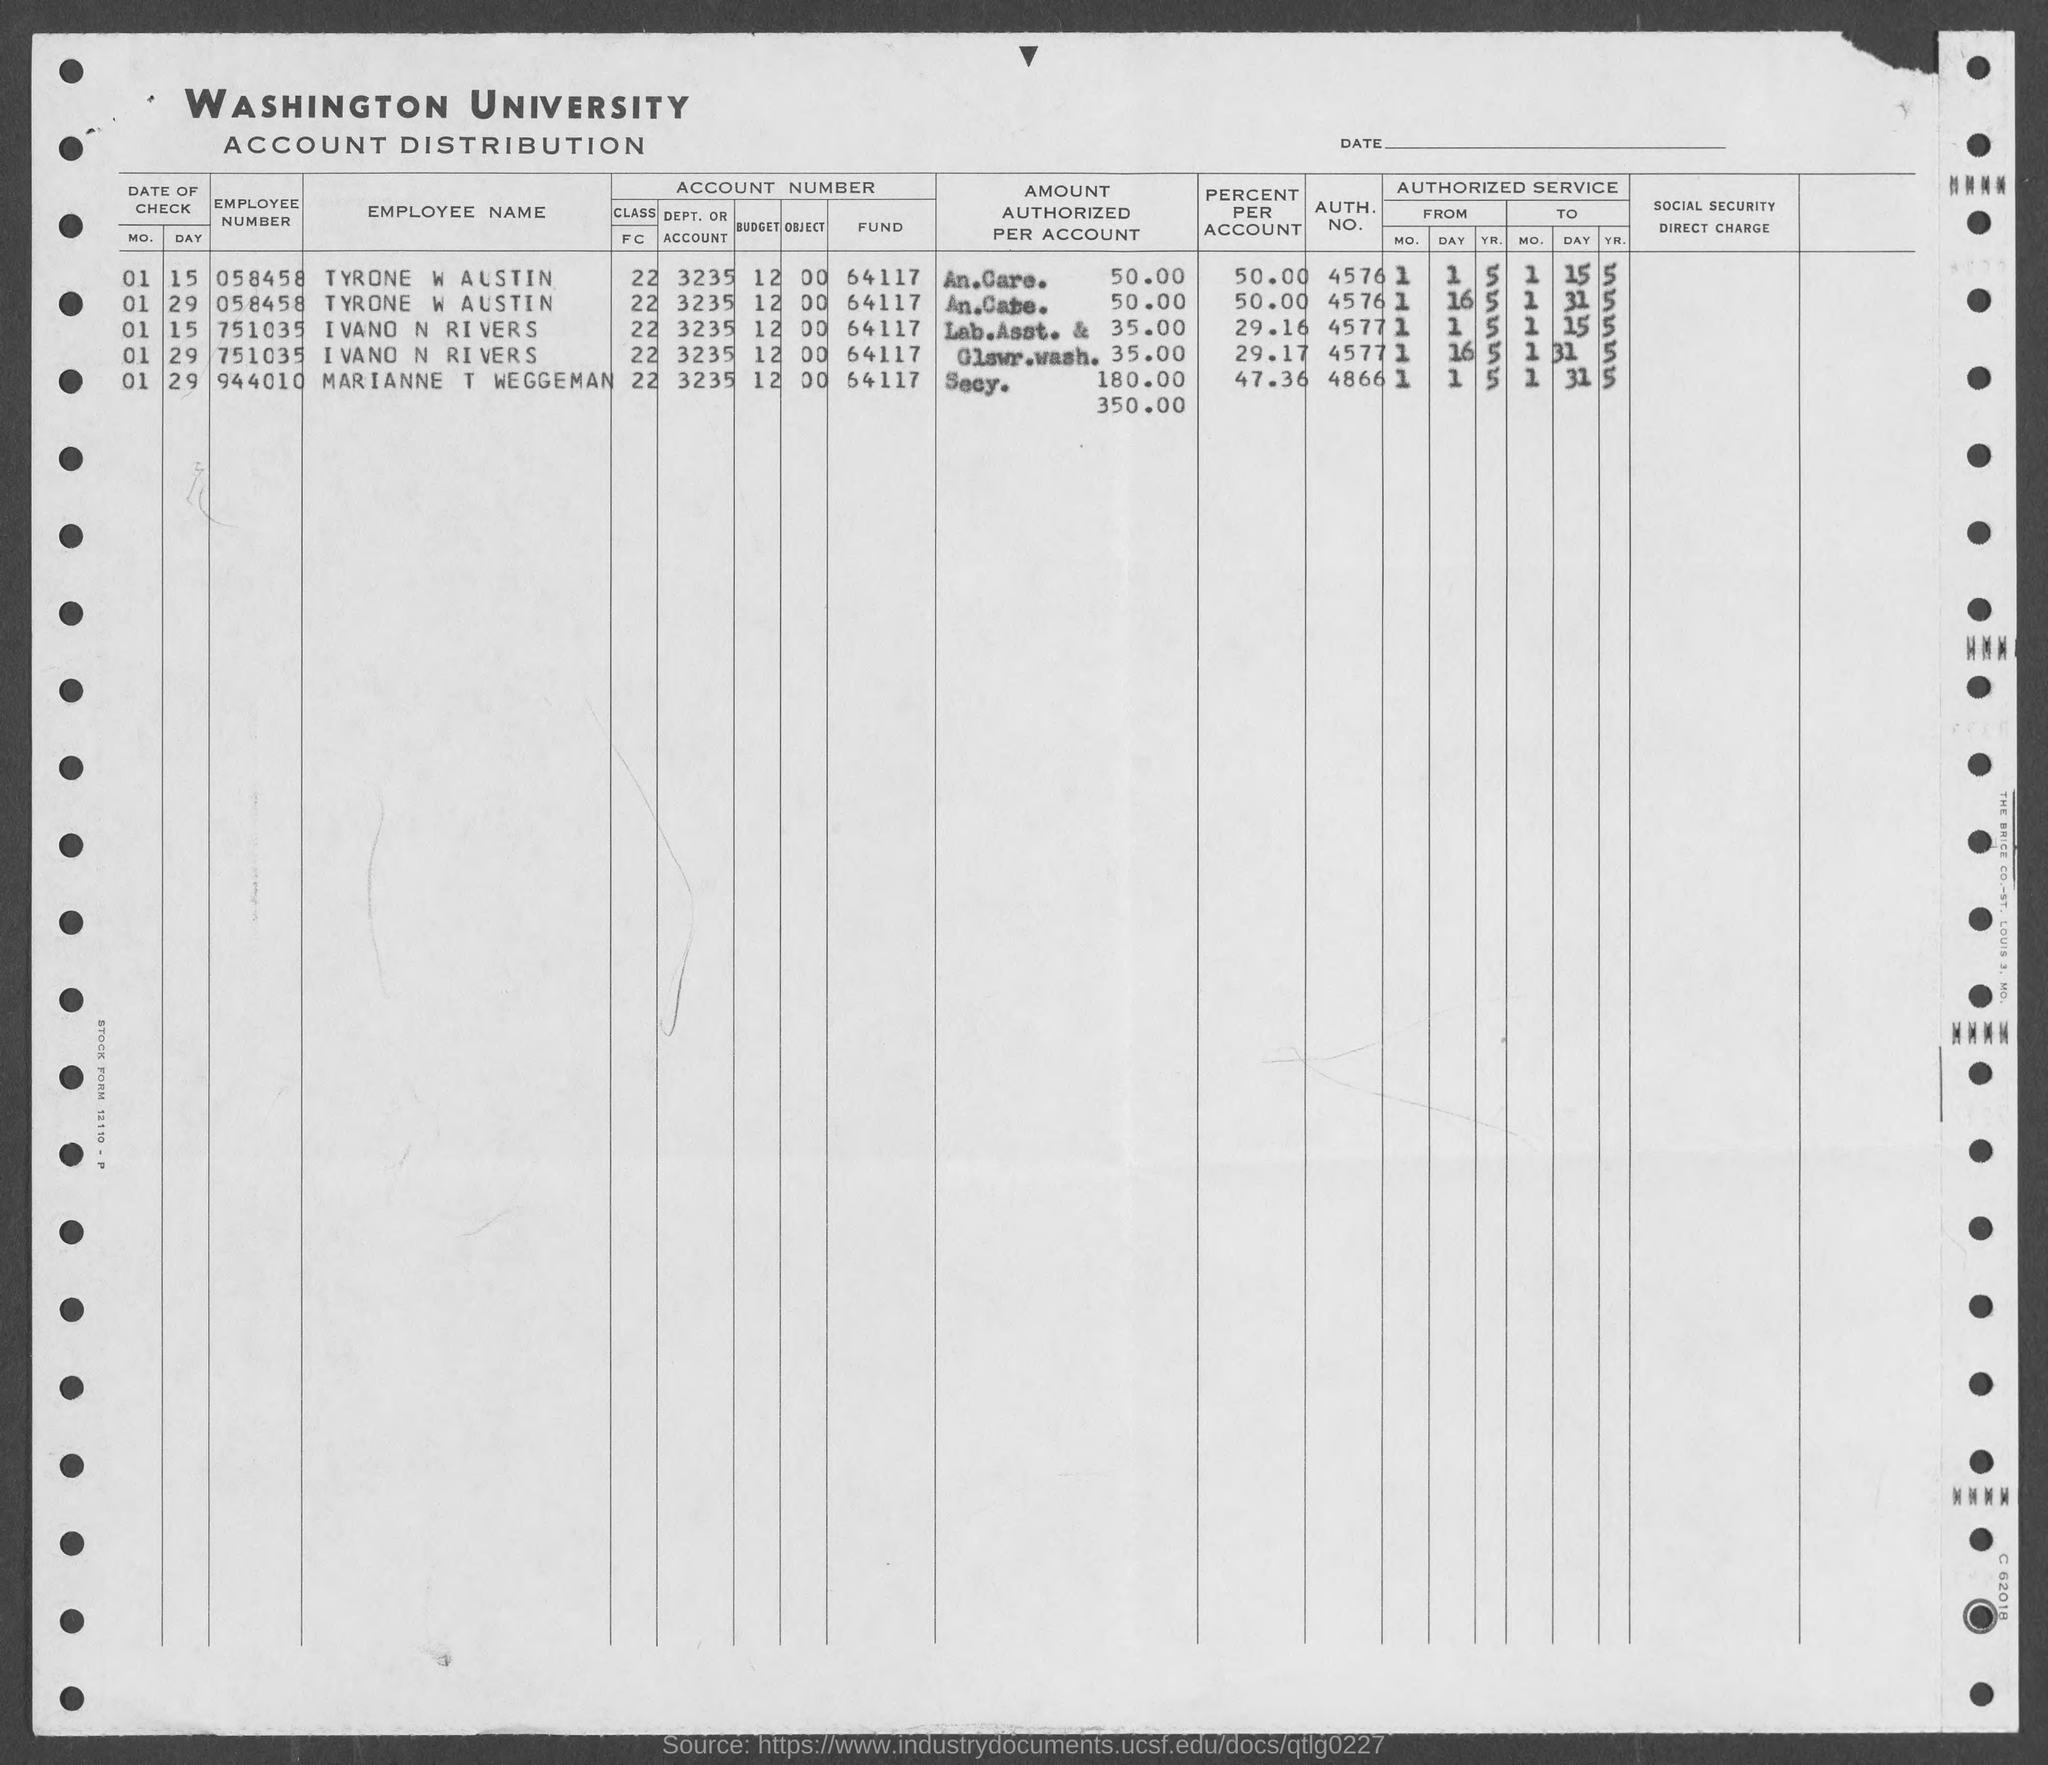What is the name of the university mentioned in the given form ?
Ensure brevity in your answer.  Washington University. What is the employee number given for tyrone w austin as mentioned in the given form ?
Give a very brief answer. 058458. What is the employee name given for the employee number 058458 as mentioned inj the given form ?
Make the answer very short. Tyrone w austin. What is the auth. no. for tyrone w austin as mentioned in the given form ?
Offer a terse response. 4576. What is the auth. no. for ivano n rivers as mentioned in the given form ?
Provide a short and direct response. 4577. What is the auth. no. marianne t weggeman as mentioned in the given form ?
Provide a short and direct response. 4866. What is the value of percent per account for tyrone w austin  as mentioned in the given form ?
Keep it short and to the point. 50.00. What is the value of percent per account for marianne t waggeman  as mentioned in the given form ?
Provide a short and direct response. 47.36. What is the employee number given for marianne t waggeman  as mentioned in the given form ?
Your response must be concise. 944010. 